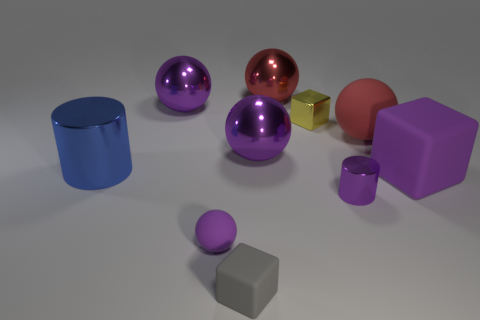There is a tiny block that is behind the small block that is in front of the purple rubber thing left of the large cube; what color is it? There appears to be a misunderstanding in the question, as the description does not match any of the objects in the image provided. To clarify, there are no tiny blocks positioned as described relative to a purple object and a large cube. 